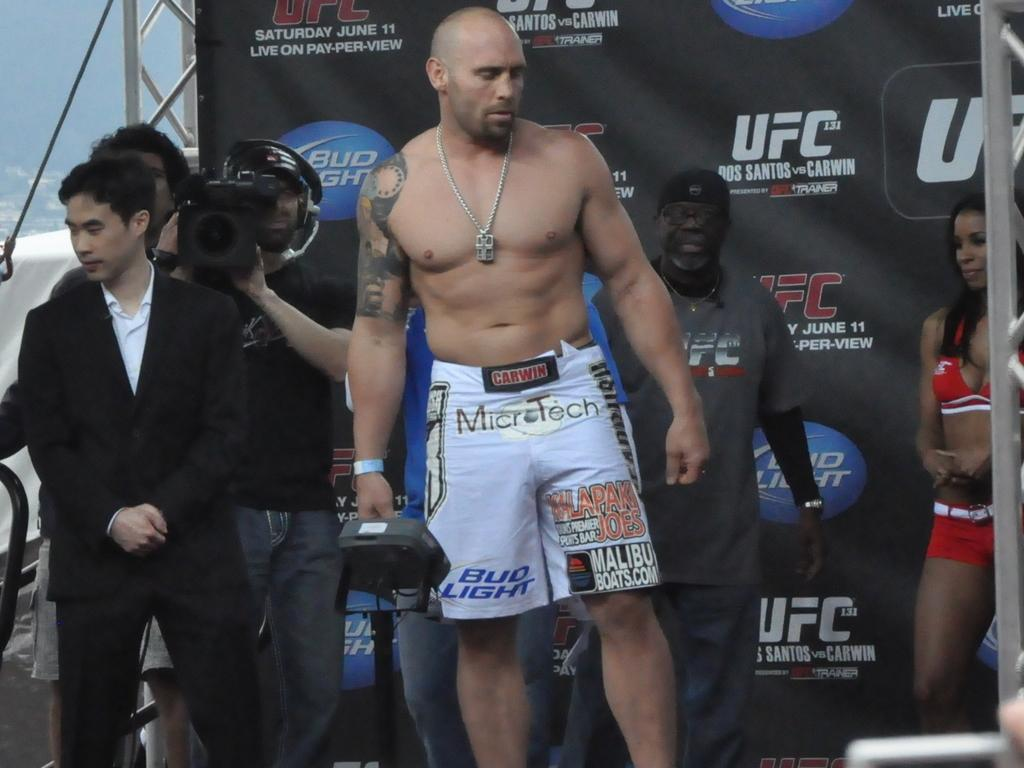<image>
Offer a succinct explanation of the picture presented. A man wearing Microtech wrestling shorts stands in front of a UFC sign 